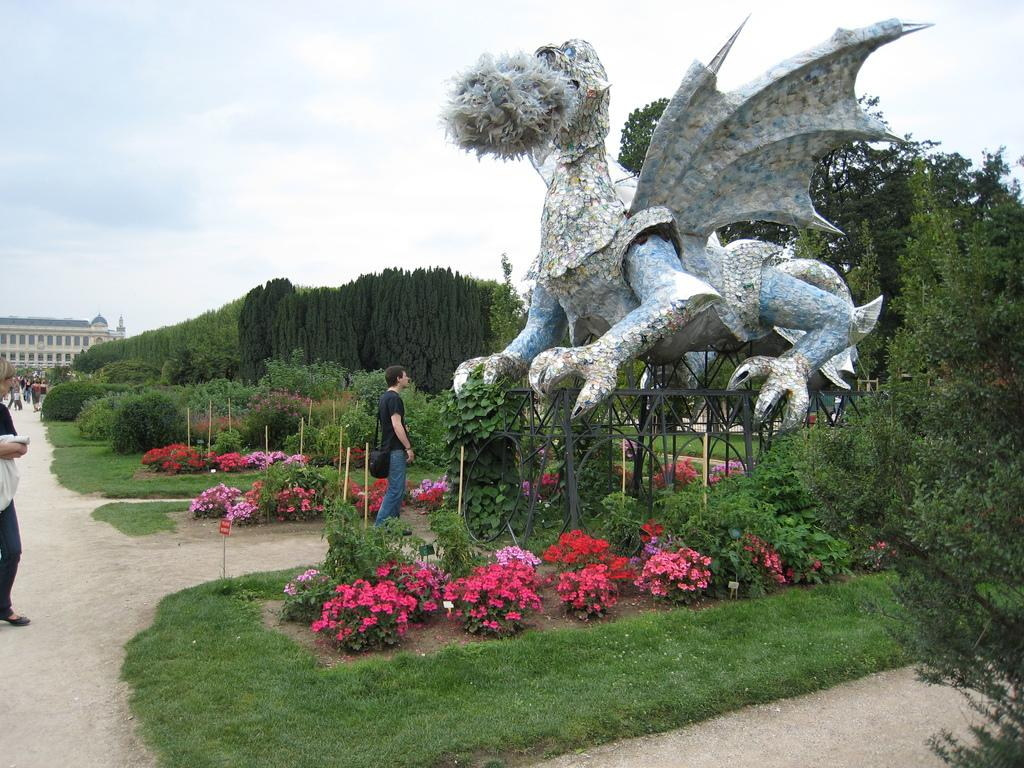How many people are in the image? There are people in the image, but the exact number is not specified. What type of natural environment is visible in the image? There is grass, plants, flowers, trees, and the sky visible in the image. What type of structure can be seen in the image? There is a building in the image. What other object can be seen in the image? There is a statue in the image. What is visible in the background of the image? The sky is visible in the background of the image, and there are clouds in the sky. What type of pot is being used to transport the flowers in the image? There is no pot or transportation of flowers visible in the image. 